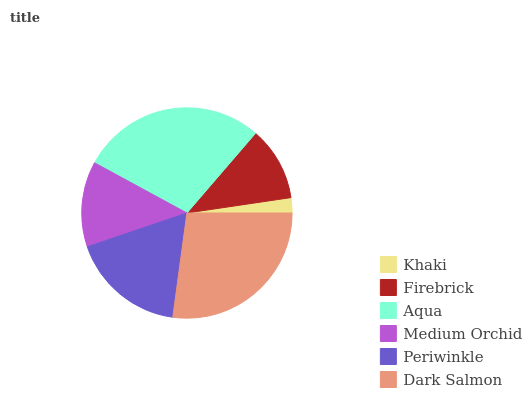Is Khaki the minimum?
Answer yes or no. Yes. Is Aqua the maximum?
Answer yes or no. Yes. Is Firebrick the minimum?
Answer yes or no. No. Is Firebrick the maximum?
Answer yes or no. No. Is Firebrick greater than Khaki?
Answer yes or no. Yes. Is Khaki less than Firebrick?
Answer yes or no. Yes. Is Khaki greater than Firebrick?
Answer yes or no. No. Is Firebrick less than Khaki?
Answer yes or no. No. Is Periwinkle the high median?
Answer yes or no. Yes. Is Medium Orchid the low median?
Answer yes or no. Yes. Is Firebrick the high median?
Answer yes or no. No. Is Aqua the low median?
Answer yes or no. No. 